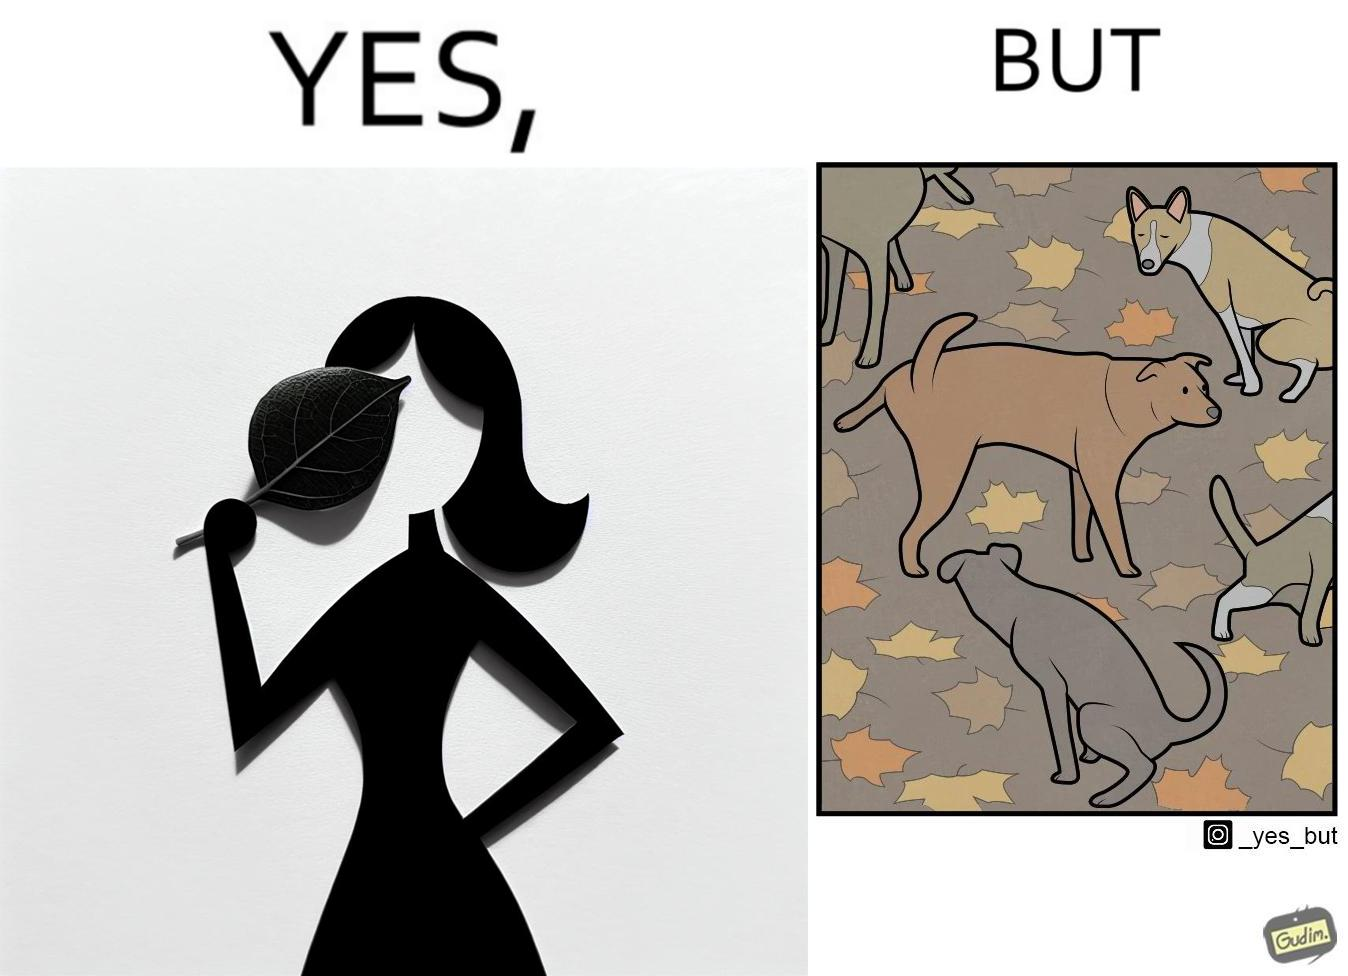Does this image contain satire or humor? Yes, this image is satirical. 